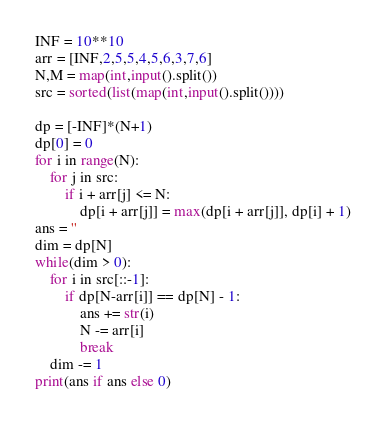<code> <loc_0><loc_0><loc_500><loc_500><_Python_>INF = 10**10
arr = [INF,2,5,5,4,5,6,3,7,6]
N,M = map(int,input().split())
src = sorted(list(map(int,input().split())))

dp = [-INF]*(N+1)
dp[0] = 0
for i in range(N):
    for j in src:
        if i + arr[j] <= N:
            dp[i + arr[j]] = max(dp[i + arr[j]], dp[i] + 1)
ans = ''
dim = dp[N]
while(dim > 0):
    for i in src[::-1]:
        if dp[N-arr[i]] == dp[N] - 1:
            ans += str(i)
            N -= arr[i]
            break
    dim -= 1
print(ans if ans else 0)</code> 